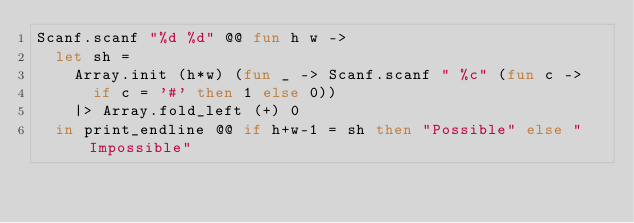<code> <loc_0><loc_0><loc_500><loc_500><_OCaml_>Scanf.scanf "%d %d" @@ fun h w ->
  let sh =
    Array.init (h*w) (fun _ -> Scanf.scanf " %c" (fun c ->
      if c = '#' then 1 else 0))
    |> Array.fold_left (+) 0
  in print_endline @@ if h+w-1 = sh then "Possible" else "Impossible"</code> 